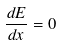<formula> <loc_0><loc_0><loc_500><loc_500>\frac { d E } { d x } = 0</formula> 